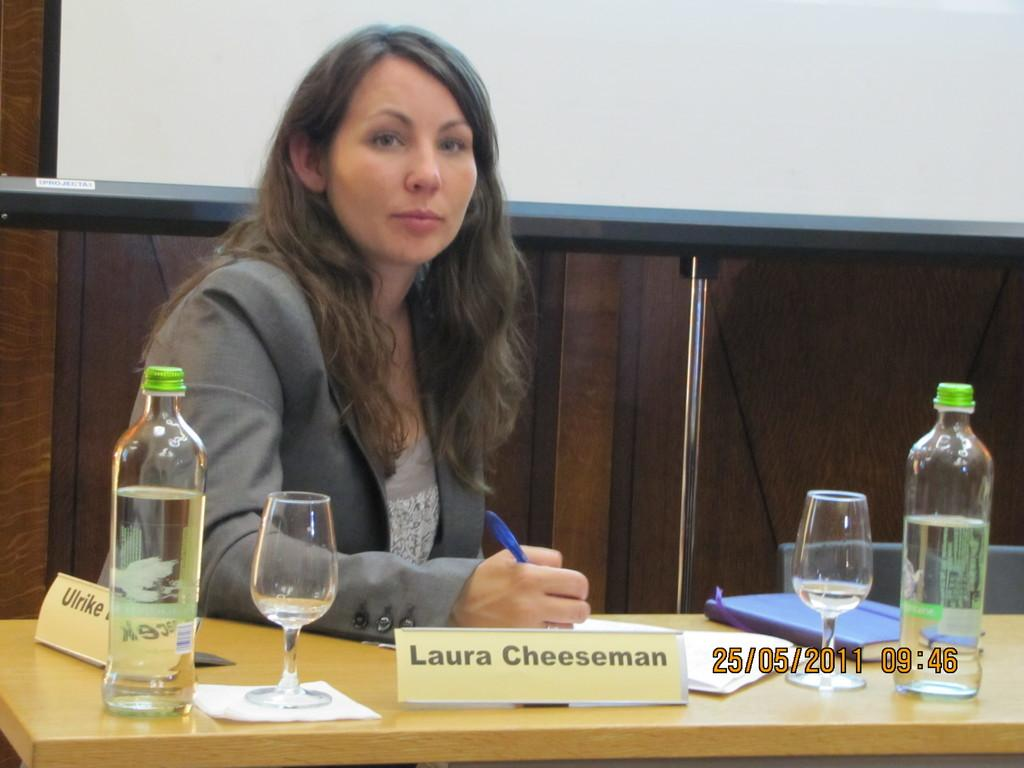What is the person in the image doing? There is a person sitting in the image. What is in front of the person? There is a table in front of the person. What can be seen on the table? There are glasses and bottles on the table. Is there any identification on the table? Yes, there is a name plate named "Laura Cheeseman" on the table. Are there any icicles hanging from the yard in the image? There is no yard or icicles present in the image; it only shows a person sitting at a table with glasses, bottles, and a name plate. 